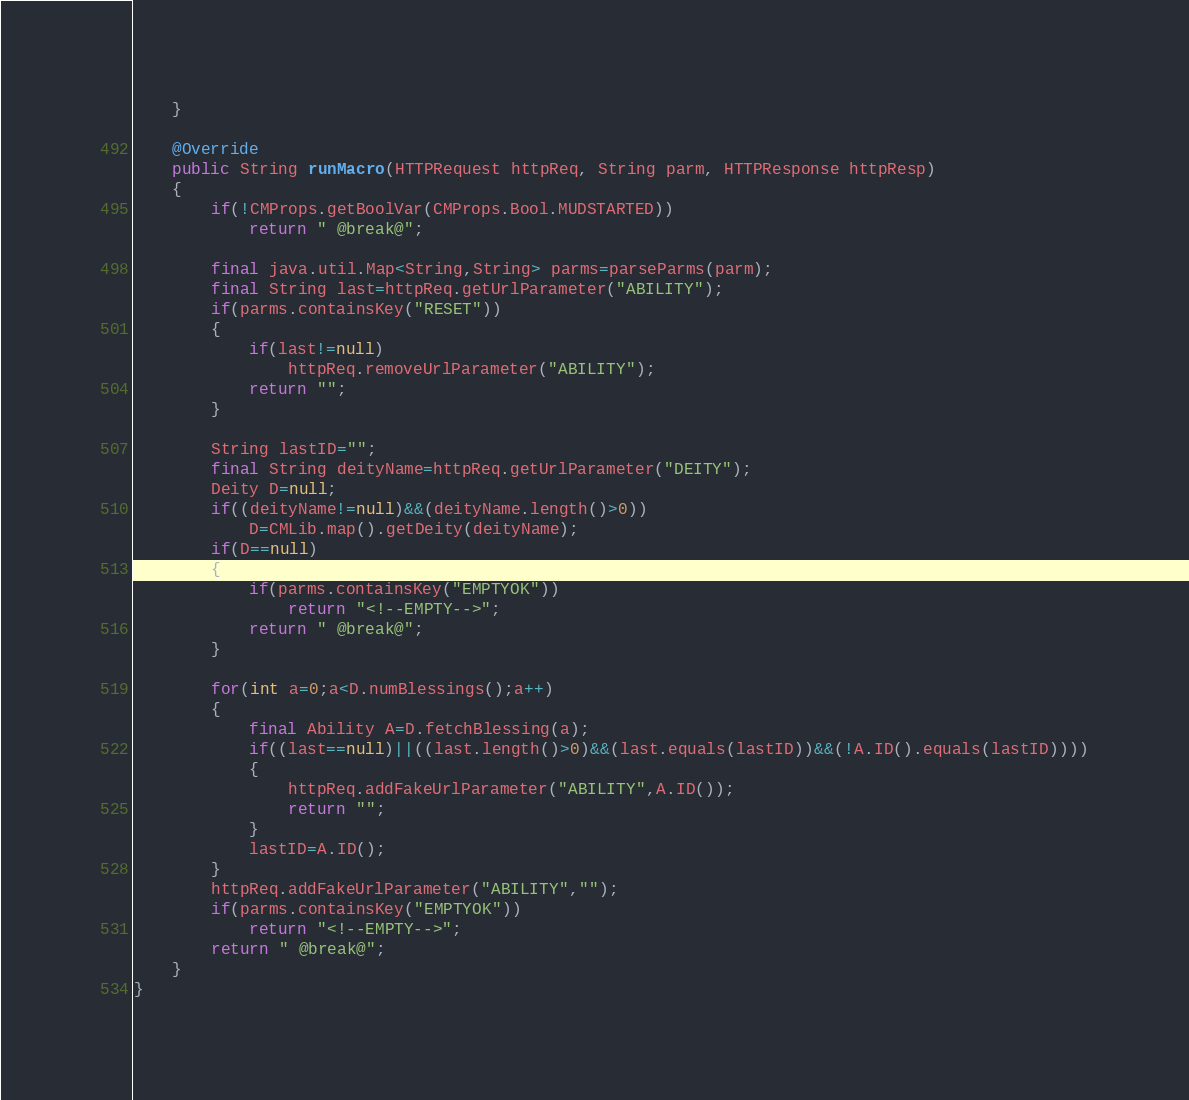Convert code to text. <code><loc_0><loc_0><loc_500><loc_500><_Java_>	}

	@Override
	public String runMacro(HTTPRequest httpReq, String parm, HTTPResponse httpResp)
	{
		if(!CMProps.getBoolVar(CMProps.Bool.MUDSTARTED))
			return " @break@";

		final java.util.Map<String,String> parms=parseParms(parm);
		final String last=httpReq.getUrlParameter("ABILITY");
		if(parms.containsKey("RESET"))
		{
			if(last!=null)
				httpReq.removeUrlParameter("ABILITY");
			return "";
		}

		String lastID="";
		final String deityName=httpReq.getUrlParameter("DEITY");
		Deity D=null;
		if((deityName!=null)&&(deityName.length()>0))
			D=CMLib.map().getDeity(deityName);
		if(D==null)
		{
			if(parms.containsKey("EMPTYOK"))
				return "<!--EMPTY-->";
			return " @break@";
		}

		for(int a=0;a<D.numBlessings();a++)
		{
			final Ability A=D.fetchBlessing(a);
			if((last==null)||((last.length()>0)&&(last.equals(lastID))&&(!A.ID().equals(lastID))))
			{
				httpReq.addFakeUrlParameter("ABILITY",A.ID());
				return "";
			}
			lastID=A.ID();
		}
		httpReq.addFakeUrlParameter("ABILITY","");
		if(parms.containsKey("EMPTYOK"))
			return "<!--EMPTY-->";
		return " @break@";
	}
}
</code> 